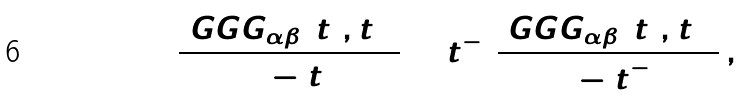<formula> <loc_0><loc_0><loc_500><loc_500>\frac { \ G G G _ { \alpha \beta } ( t _ { 2 } , t _ { 3 } ) } { 1 - t _ { 1 } } + t _ { 1 } ^ { - 1 } \frac { \ G G G _ { \alpha \beta } ( t _ { 2 } , t _ { 3 } ) } { 1 - t _ { 1 } ^ { - 1 } } \, ,</formula> 